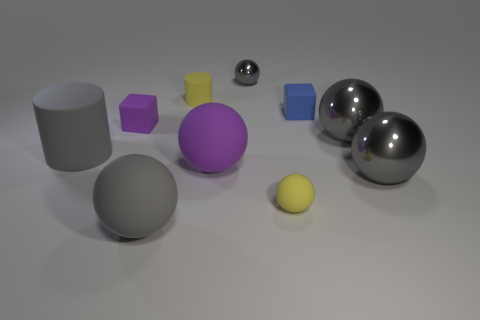How many gray spheres must be subtracted to get 1 gray spheres? 3 Subtract all purple cylinders. How many gray spheres are left? 4 Subtract all yellow spheres. How many spheres are left? 5 Subtract all big shiny balls. How many balls are left? 4 Subtract 2 spheres. How many spheres are left? 4 Subtract all cyan spheres. Subtract all red cylinders. How many spheres are left? 6 Subtract all cubes. How many objects are left? 8 Add 1 gray matte cylinders. How many gray matte cylinders are left? 2 Add 8 large yellow shiny cubes. How many large yellow shiny cubes exist? 8 Subtract 0 green blocks. How many objects are left? 10 